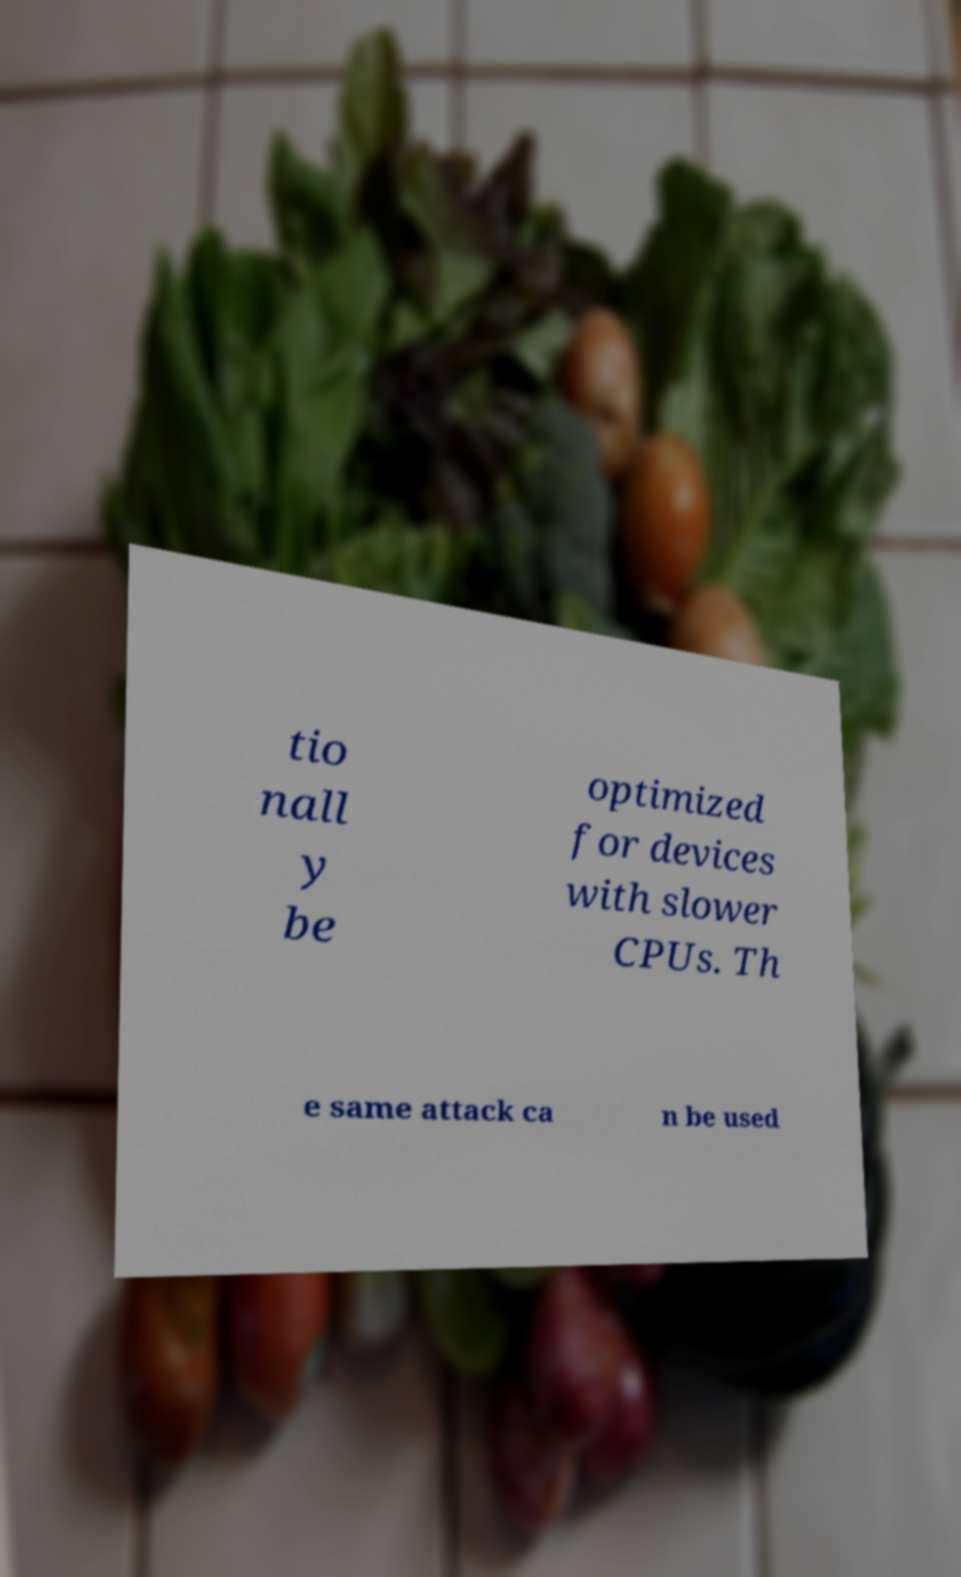I need the written content from this picture converted into text. Can you do that? tio nall y be optimized for devices with slower CPUs. Th e same attack ca n be used 